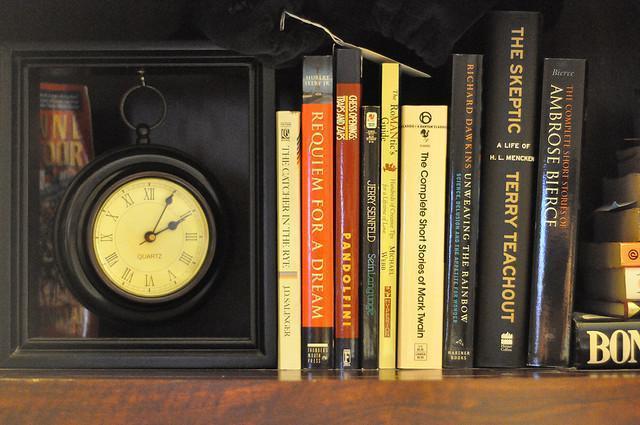How many clocks are visible?
Give a very brief answer. 1. How many books can you see?
Give a very brief answer. 9. 